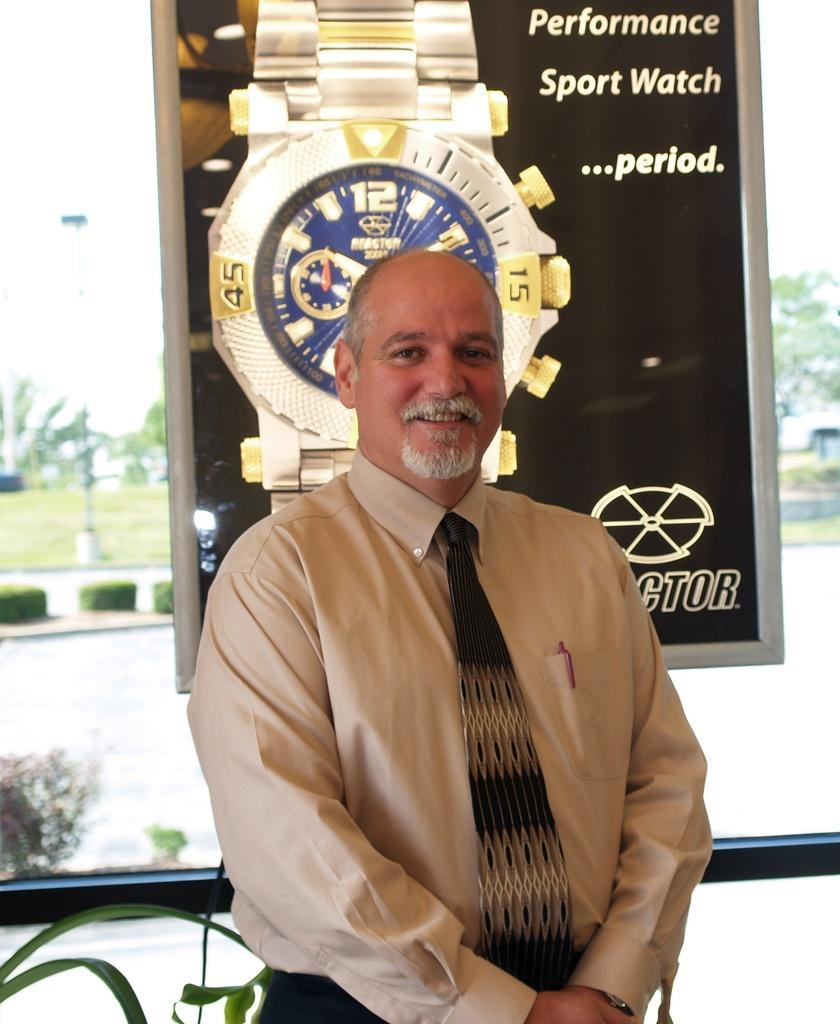Provide a one-sentence caption for the provided image. A man stands in front of a poster for a sport watch. 